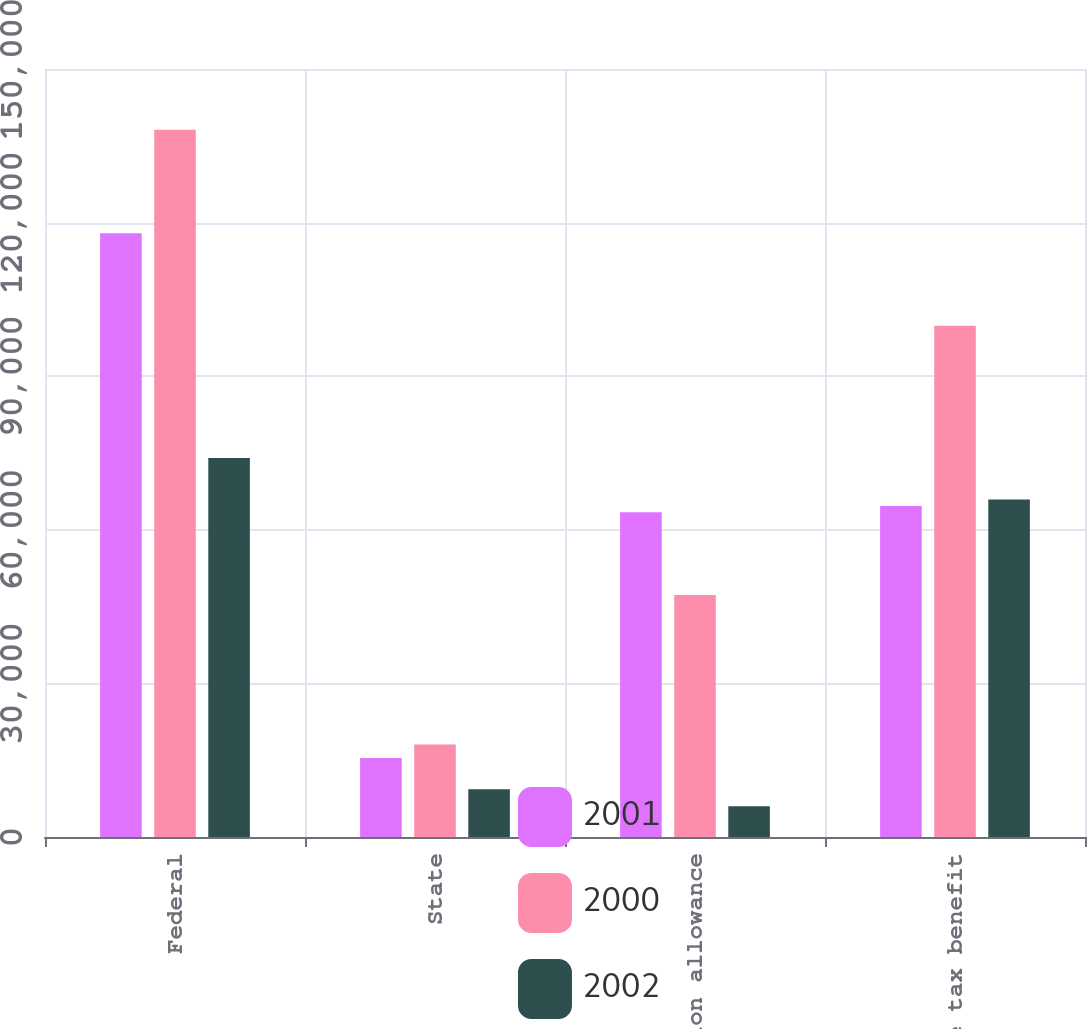<chart> <loc_0><loc_0><loc_500><loc_500><stacked_bar_chart><ecel><fcel>Federal<fcel>State<fcel>Valuation allowance<fcel>Income tax benefit<nl><fcel>2001<fcel>117929<fcel>15435<fcel>63413<fcel>64634<nl><fcel>2000<fcel>138142<fcel>18081<fcel>47248<fcel>99875<nl><fcel>2002<fcel>74029<fcel>9338<fcel>5987<fcel>65897<nl></chart> 